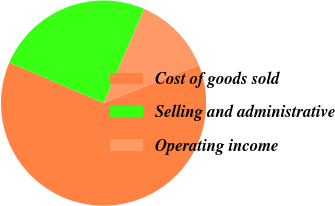<chart> <loc_0><loc_0><loc_500><loc_500><pie_chart><fcel>Cost of goods sold<fcel>Selling and administrative<fcel>Operating income<nl><fcel>62.53%<fcel>25.01%<fcel>12.46%<nl></chart> 